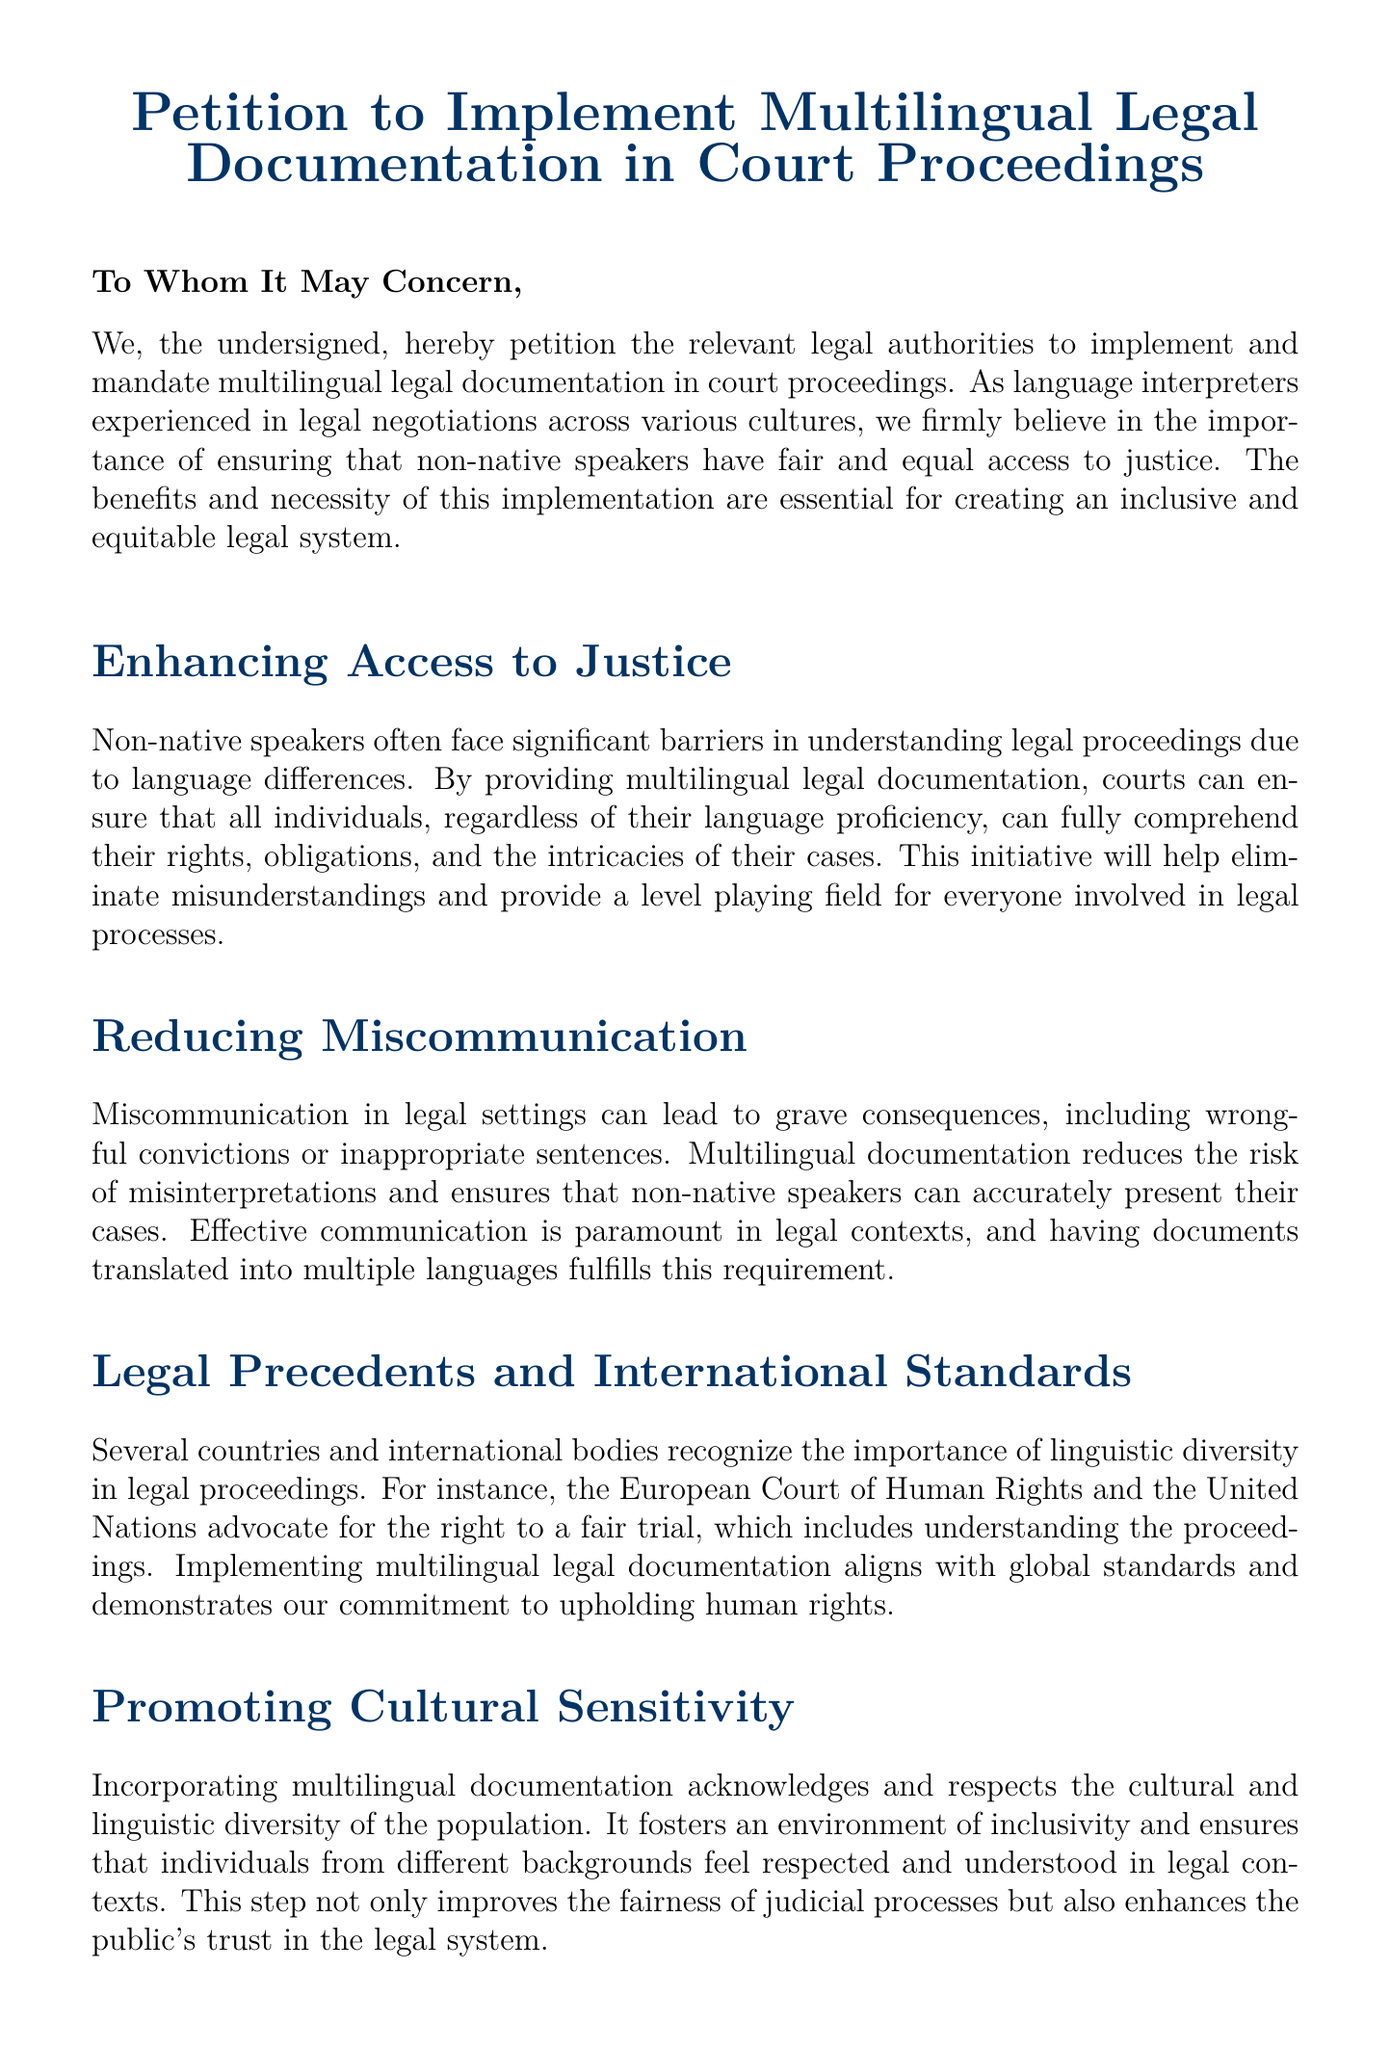What is the title of the document? The title of the document is prominently displayed at the top, stating the primary focus.
Answer: Petition to Implement Multilingual Legal Documentation in Court Proceedings Who is the audience of the petition? The introduction of the petition indicates to whom the document is addressed, showing the intended recipients.
Answer: To Whom It May Concern What issue does the petition primarily address? The main focus of the petition is described, addressing the necessity for multilingual support in legal contexts.
Answer: Multilingual legal documentation What is one benefit mentioned for implementing multilingual documentation? The paragraph on "Enhancing Access to Justice" lists specific advantages that will arise from the implementation.
Answer: Fair access to justice Which international body is mentioned in the petition as supporting linguistic diversity? In the section discussing legal precedents, one particular organization supporting this initiative is identified.
Answer: United Nations How does multilingual documentation contribute to legal proceedings? The section on reducing miscommunication outlines how this documentation affects clarity within legal processes.
Answer: Reduces misinterpretations What is the overall conclusion drawn in the petition? The concluding remarks summarize the necessity and benefits of the proposal outlined in the document.
Answer: Pressing necessity What role does the petitioner claim to hold? The closing part of the document identifies the professional role of the signer advocating for the proposal.
Answer: Interpreter & Advocate for Multicultural Legal Representation 